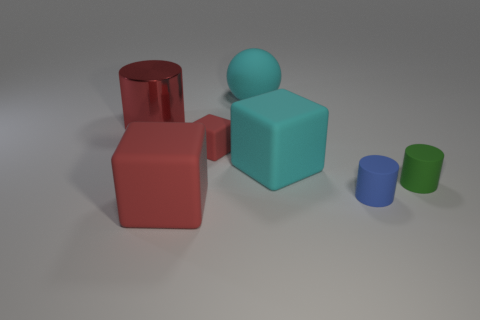Add 2 cubes. How many objects exist? 9 Subtract all cylinders. How many objects are left? 4 Add 4 tiny blue cylinders. How many tiny blue cylinders are left? 5 Add 1 small green matte objects. How many small green matte objects exist? 2 Subtract 1 cyan cubes. How many objects are left? 6 Subtract all matte cylinders. Subtract all tiny rubber things. How many objects are left? 2 